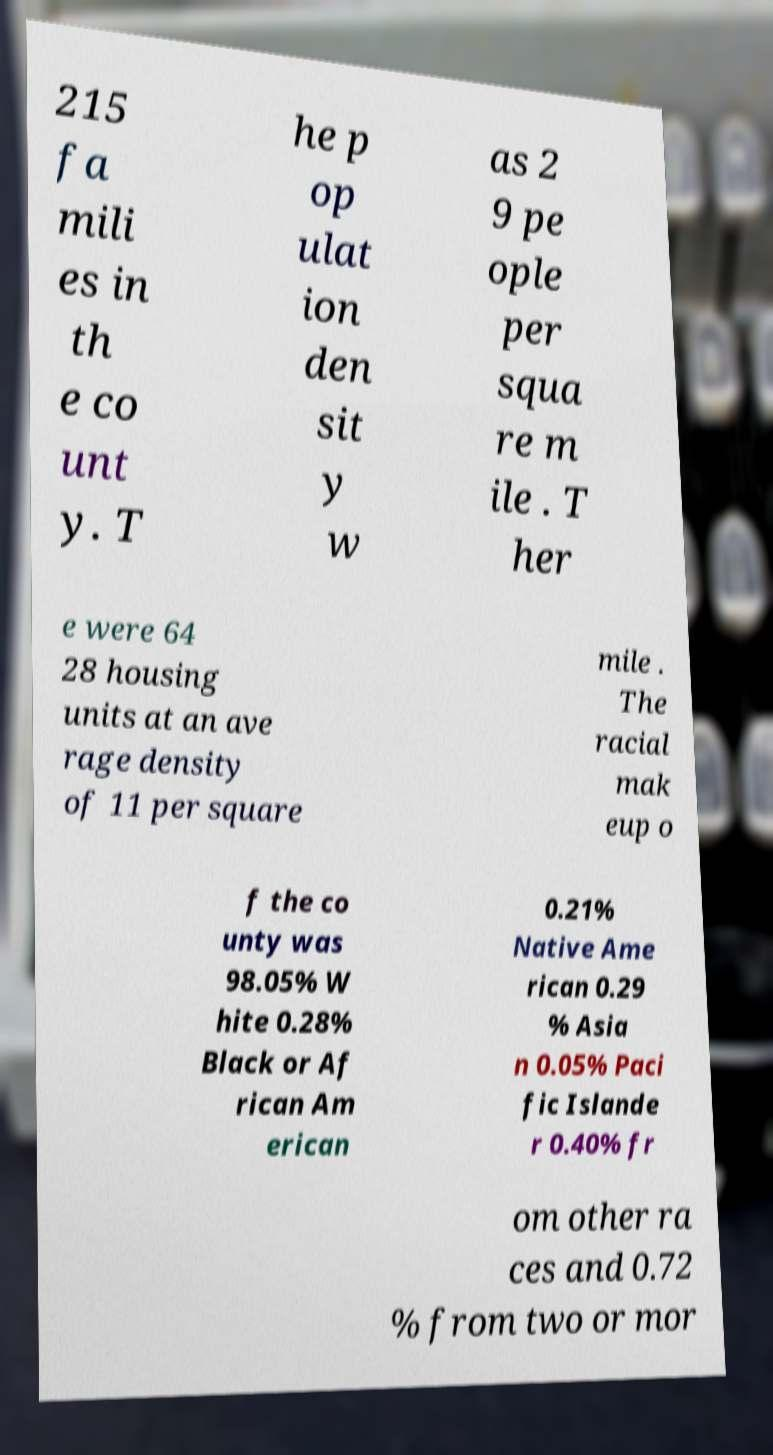Could you extract and type out the text from this image? 215 fa mili es in th e co unt y. T he p op ulat ion den sit y w as 2 9 pe ople per squa re m ile . T her e were 64 28 housing units at an ave rage density of 11 per square mile . The racial mak eup o f the co unty was 98.05% W hite 0.28% Black or Af rican Am erican 0.21% Native Ame rican 0.29 % Asia n 0.05% Paci fic Islande r 0.40% fr om other ra ces and 0.72 % from two or mor 